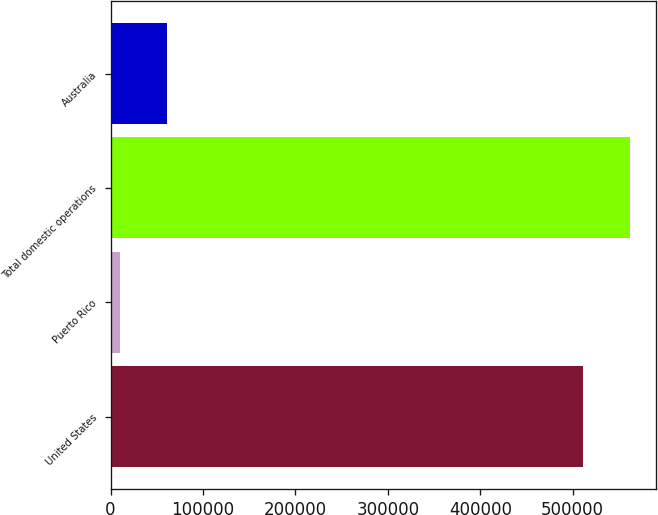<chart> <loc_0><loc_0><loc_500><loc_500><bar_chart><fcel>United States<fcel>Puerto Rico<fcel>Total domestic operations<fcel>Australia<nl><fcel>510669<fcel>10033<fcel>561736<fcel>61099.9<nl></chart> 